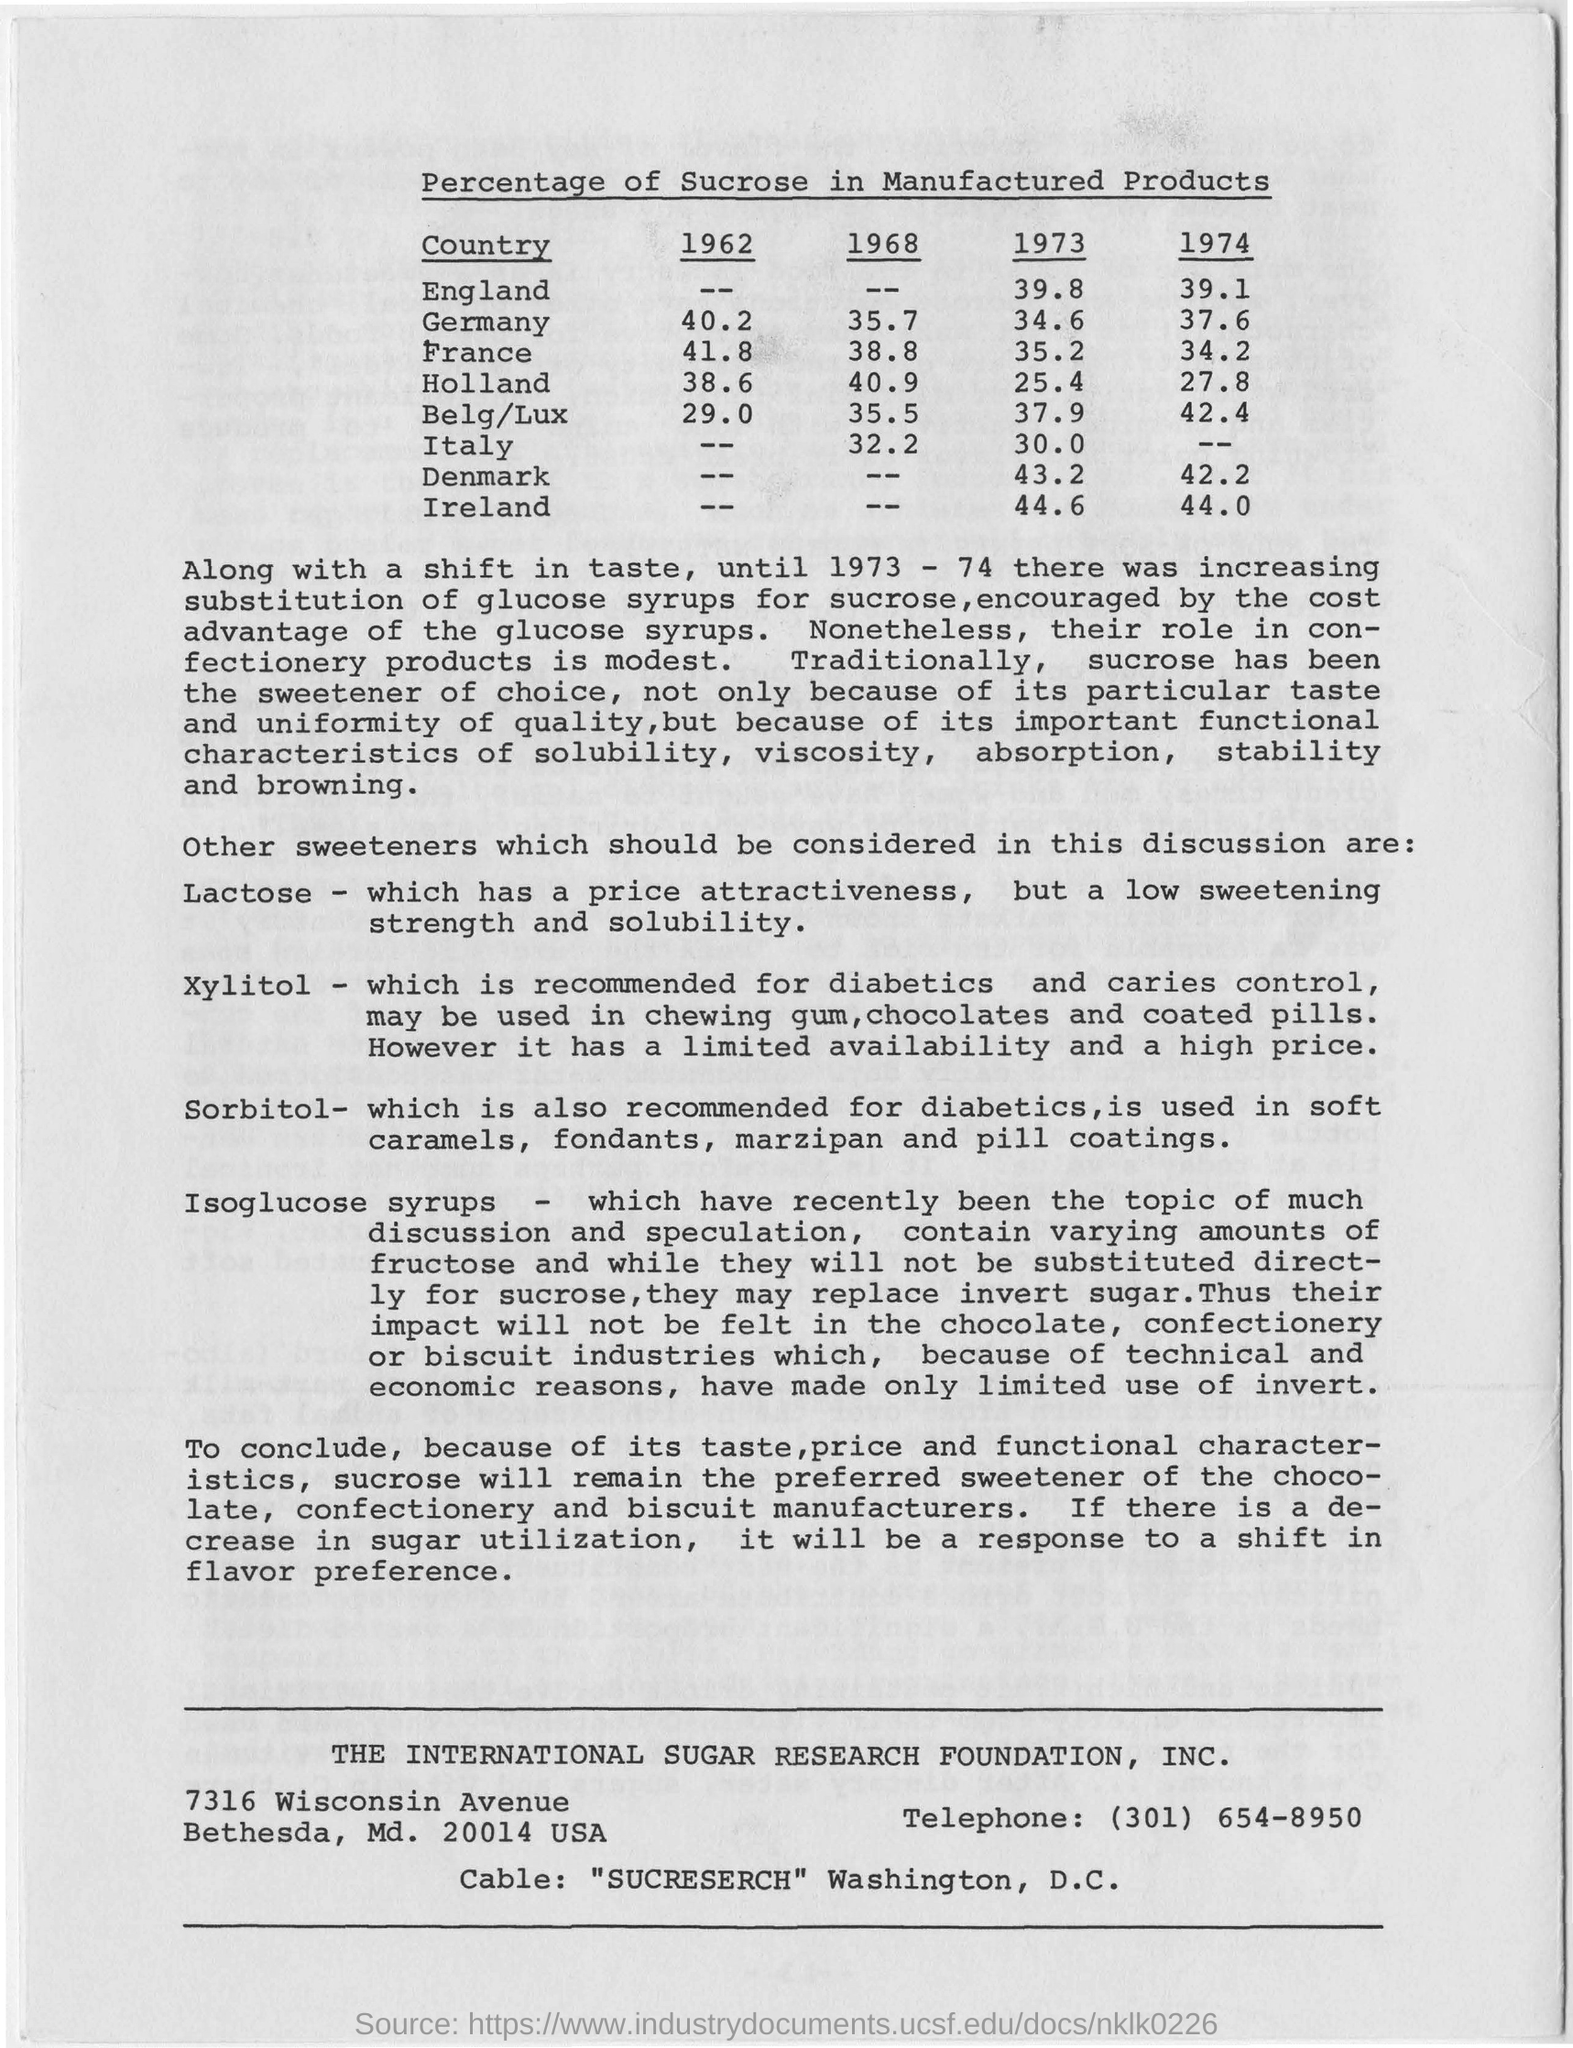What is the Percentage of Sucrose in Manufactured Products in 1973 in England?
Keep it short and to the point. 39.8. What is the Percentage of Sucrose in Manufactured Products in 1962 in Germany?
Offer a very short reply. 40.2. Until Which year there was increasing substitution of glucose syrups for sucrose?
Your response must be concise. 1973 - 74. What is the Percentage of sucrose in Manufactured Products in 1973 in Italy?
Provide a succinct answer. 30.0. 